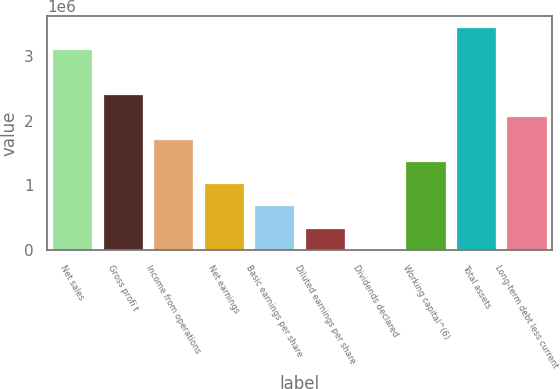<chart> <loc_0><loc_0><loc_500><loc_500><bar_chart><fcel>Net sales<fcel>Gross profi t<fcel>Income from operations<fcel>Net earnings<fcel>Basic earnings per share<fcel>Diluted earnings per share<fcel>Dividends declared<fcel>Working capital^(6)<fcel>Total assets<fcel>Long-term debt less current<nl><fcel>3.10787e+06<fcel>2.41723e+06<fcel>1.72659e+06<fcel>1.03596e+06<fcel>690637<fcel>345319<fcel>0.27<fcel>1.38127e+06<fcel>3.45318e+06<fcel>2.07191e+06<nl></chart> 